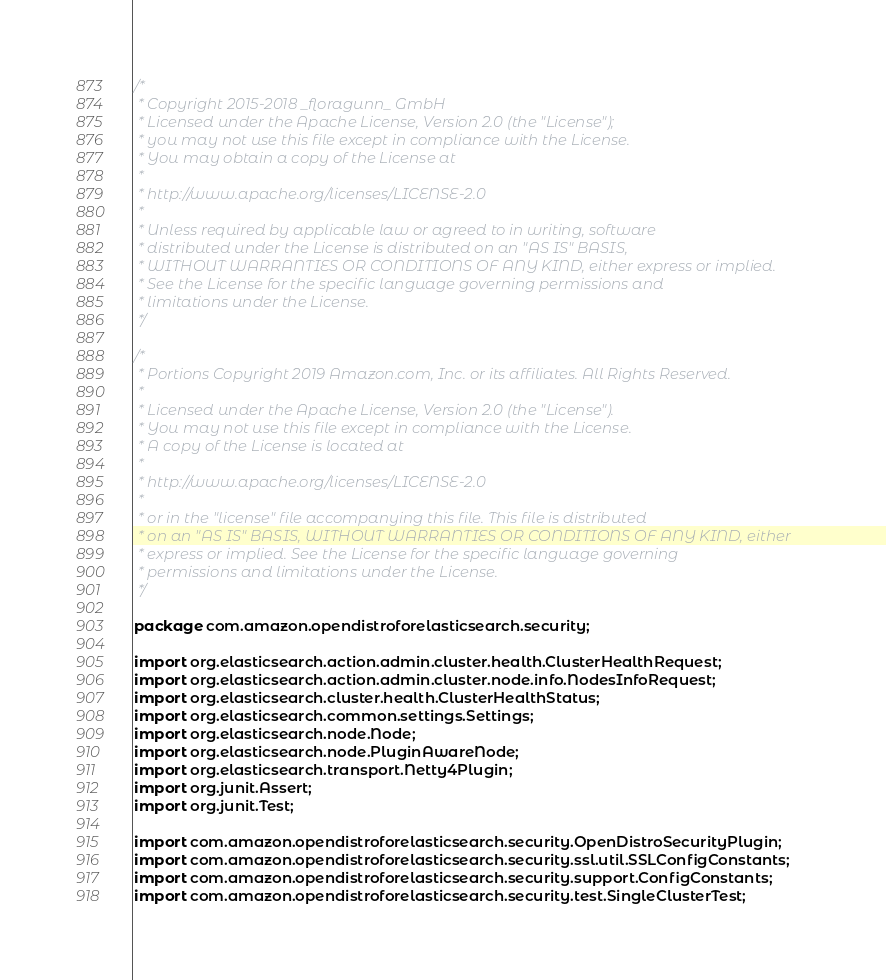<code> <loc_0><loc_0><loc_500><loc_500><_Java_>/*
 * Copyright 2015-2018 _floragunn_ GmbH
 * Licensed under the Apache License, Version 2.0 (the "License");
 * you may not use this file except in compliance with the License.
 * You may obtain a copy of the License at
 *
 * http://www.apache.org/licenses/LICENSE-2.0
 *
 * Unless required by applicable law or agreed to in writing, software
 * distributed under the License is distributed on an "AS IS" BASIS,
 * WITHOUT WARRANTIES OR CONDITIONS OF ANY KIND, either express or implied.
 * See the License for the specific language governing permissions and
 * limitations under the License.
 */

/*
 * Portions Copyright 2019 Amazon.com, Inc. or its affiliates. All Rights Reserved.
 *
 * Licensed under the Apache License, Version 2.0 (the "License").
 * You may not use this file except in compliance with the License.
 * A copy of the License is located at
 *
 * http://www.apache.org/licenses/LICENSE-2.0
 *
 * or in the "license" file accompanying this file. This file is distributed
 * on an "AS IS" BASIS, WITHOUT WARRANTIES OR CONDITIONS OF ANY KIND, either
 * express or implied. See the License for the specific language governing
 * permissions and limitations under the License.
 */

package com.amazon.opendistroforelasticsearch.security;

import org.elasticsearch.action.admin.cluster.health.ClusterHealthRequest;
import org.elasticsearch.action.admin.cluster.node.info.NodesInfoRequest;
import org.elasticsearch.cluster.health.ClusterHealthStatus;
import org.elasticsearch.common.settings.Settings;
import org.elasticsearch.node.Node;
import org.elasticsearch.node.PluginAwareNode;
import org.elasticsearch.transport.Netty4Plugin;
import org.junit.Assert;
import org.junit.Test;

import com.amazon.opendistroforelasticsearch.security.OpenDistroSecurityPlugin;
import com.amazon.opendistroforelasticsearch.security.ssl.util.SSLConfigConstants;
import com.amazon.opendistroforelasticsearch.security.support.ConfigConstants;
import com.amazon.opendistroforelasticsearch.security.test.SingleClusterTest;</code> 